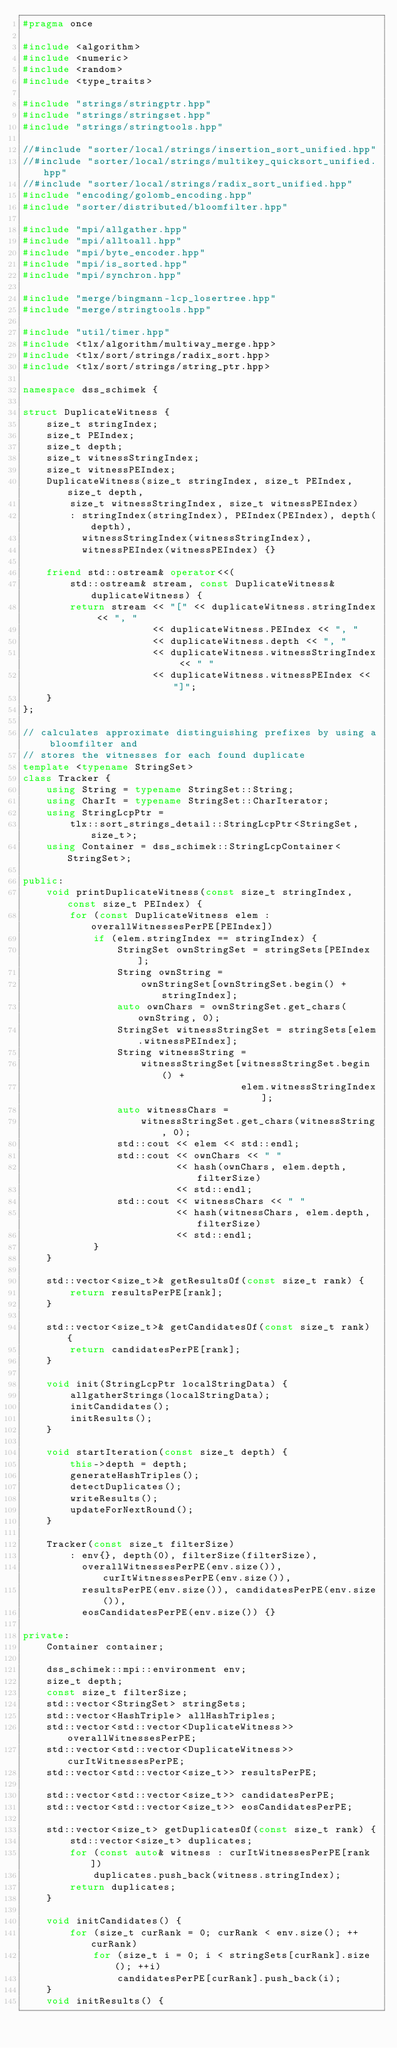Convert code to text. <code><loc_0><loc_0><loc_500><loc_500><_C++_>#pragma once

#include <algorithm>
#include <numeric>
#include <random>
#include <type_traits>

#include "strings/stringptr.hpp"
#include "strings/stringset.hpp"
#include "strings/stringtools.hpp"

//#include "sorter/local/strings/insertion_sort_unified.hpp"
//#include "sorter/local/strings/multikey_quicksort_unified.hpp"
//#include "sorter/local/strings/radix_sort_unified.hpp"
#include "encoding/golomb_encoding.hpp"
#include "sorter/distributed/bloomfilter.hpp"

#include "mpi/allgather.hpp"
#include "mpi/alltoall.hpp"
#include "mpi/byte_encoder.hpp"
#include "mpi/is_sorted.hpp"
#include "mpi/synchron.hpp"

#include "merge/bingmann-lcp_losertree.hpp"
#include "merge/stringtools.hpp"

#include "util/timer.hpp"
#include <tlx/algorithm/multiway_merge.hpp>
#include <tlx/sort/strings/radix_sort.hpp>
#include <tlx/sort/strings/string_ptr.hpp>

namespace dss_schimek {

struct DuplicateWitness {
    size_t stringIndex;
    size_t PEIndex;
    size_t depth;
    size_t witnessStringIndex;
    size_t witnessPEIndex;
    DuplicateWitness(size_t stringIndex, size_t PEIndex, size_t depth,
        size_t witnessStringIndex, size_t witnessPEIndex)
        : stringIndex(stringIndex), PEIndex(PEIndex), depth(depth),
          witnessStringIndex(witnessStringIndex),
          witnessPEIndex(witnessPEIndex) {}

    friend std::ostream& operator<<(
        std::ostream& stream, const DuplicateWitness& duplicateWitness) {
        return stream << "[" << duplicateWitness.stringIndex << ", "
                      << duplicateWitness.PEIndex << ", "
                      << duplicateWitness.depth << ", "
                      << duplicateWitness.witnessStringIndex << " "
                      << duplicateWitness.witnessPEIndex << "]";
    }
};

// calculates approximate distinguishing prefixes by using a bloomfilter and
// stores the witnesses for each found duplicate
template <typename StringSet>
class Tracker {
    using String = typename StringSet::String;
    using CharIt = typename StringSet::CharIterator;
    using StringLcpPtr =
        tlx::sort_strings_detail::StringLcpPtr<StringSet, size_t>;
    using Container = dss_schimek::StringLcpContainer<StringSet>;

public:
    void printDuplicateWitness(const size_t stringIndex, const size_t PEIndex) {
        for (const DuplicateWitness elem : overallWitnessesPerPE[PEIndex])
            if (elem.stringIndex == stringIndex) {
                StringSet ownStringSet = stringSets[PEIndex];
                String ownString =
                    ownStringSet[ownStringSet.begin() + stringIndex];
                auto ownChars = ownStringSet.get_chars(ownString, 0);
                StringSet witnessStringSet = stringSets[elem.witnessPEIndex];
                String witnessString =
                    witnessStringSet[witnessStringSet.begin() +
                                     elem.witnessStringIndex];
                auto witnessChars =
                    witnessStringSet.get_chars(witnessString, 0);
                std::cout << elem << std::endl;
                std::cout << ownChars << " "
                          << hash(ownChars, elem.depth, filterSize)
                          << std::endl;
                std::cout << witnessChars << " "
                          << hash(witnessChars, elem.depth, filterSize)
                          << std::endl;
            }
    }

    std::vector<size_t>& getResultsOf(const size_t rank) {
        return resultsPerPE[rank];
    }

    std::vector<size_t>& getCandidatesOf(const size_t rank) {
        return candidatesPerPE[rank];
    }

    void init(StringLcpPtr localStringData) {
        allgatherStrings(localStringData);
        initCandidates();
        initResults();
    }

    void startIteration(const size_t depth) {
        this->depth = depth;
        generateHashTriples();
        detectDuplicates();
        writeResults();
        updateForNextRound();
    }

    Tracker(const size_t filterSize)
        : env{}, depth(0), filterSize(filterSize),
          overallWitnessesPerPE(env.size()), curItWitnessesPerPE(env.size()),
          resultsPerPE(env.size()), candidatesPerPE(env.size()),
          eosCandidatesPerPE(env.size()) {}

private:
    Container container;

    dss_schimek::mpi::environment env;
    size_t depth;
    const size_t filterSize;
    std::vector<StringSet> stringSets;
    std::vector<HashTriple> allHashTriples;
    std::vector<std::vector<DuplicateWitness>> overallWitnessesPerPE;
    std::vector<std::vector<DuplicateWitness>> curItWitnessesPerPE;
    std::vector<std::vector<size_t>> resultsPerPE;

    std::vector<std::vector<size_t>> candidatesPerPE;
    std::vector<std::vector<size_t>> eosCandidatesPerPE;

    std::vector<size_t> getDuplicatesOf(const size_t rank) {
        std::vector<size_t> duplicates;
        for (const auto& witness : curItWitnessesPerPE[rank])
            duplicates.push_back(witness.stringIndex);
        return duplicates;
    }

    void initCandidates() {
        for (size_t curRank = 0; curRank < env.size(); ++curRank)
            for (size_t i = 0; i < stringSets[curRank].size(); ++i)
                candidatesPerPE[curRank].push_back(i);
    }
    void initResults() {</code> 